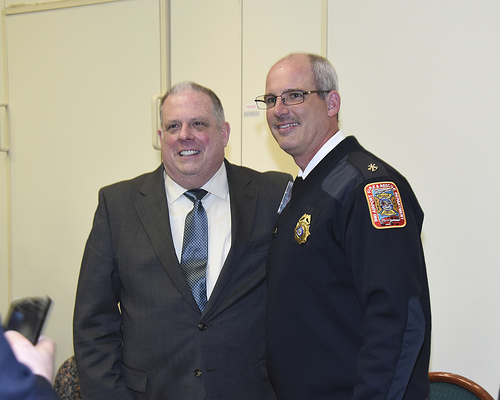<image>
Is there a medal on the man? No. The medal is not positioned on the man. They may be near each other, but the medal is not supported by or resting on top of the man. Is the man in front of the door? Yes. The man is positioned in front of the door, appearing closer to the camera viewpoint. 